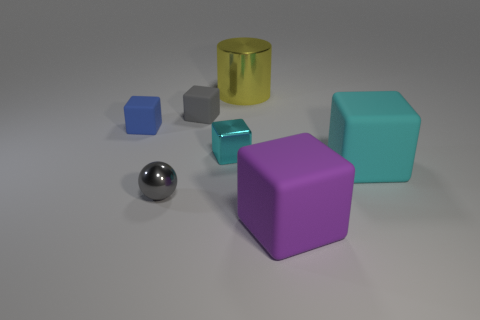What number of blocks have the same color as the small metallic sphere?
Ensure brevity in your answer.  1. There is a shiny object that is behind the cyan block that is behind the cyan matte block; is there a small blue object left of it?
Your response must be concise. Yes. There is a cyan thing on the right side of the cyan shiny cube; is its shape the same as the large purple matte thing?
Provide a succinct answer. Yes. The tiny block that is the same material as the large yellow cylinder is what color?
Provide a succinct answer. Cyan. How many other large cylinders have the same material as the large yellow cylinder?
Ensure brevity in your answer.  0. What color is the small rubber cube that is in front of the tiny rubber thing right of the metallic object that is left of the small cyan block?
Make the answer very short. Blue. Do the gray block and the yellow shiny object have the same size?
Your response must be concise. No. Is there anything else that has the same shape as the big metal thing?
Provide a succinct answer. No. What number of objects are either tiny rubber cubes that are on the right side of the gray metal ball or tiny blue blocks?
Your response must be concise. 2. Does the small blue rubber object have the same shape as the cyan metallic thing?
Make the answer very short. Yes. 